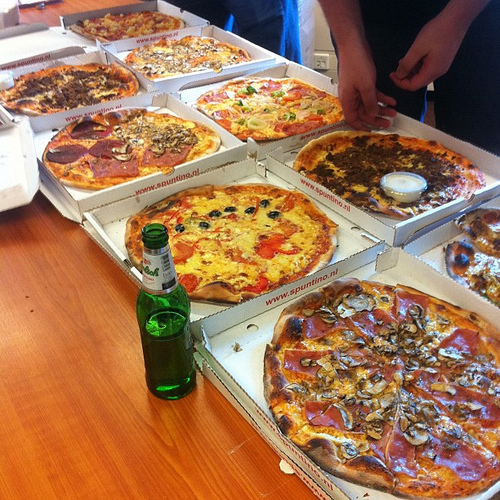Is the blue cheese in a container? Yes, the blue cheese is in a container. 